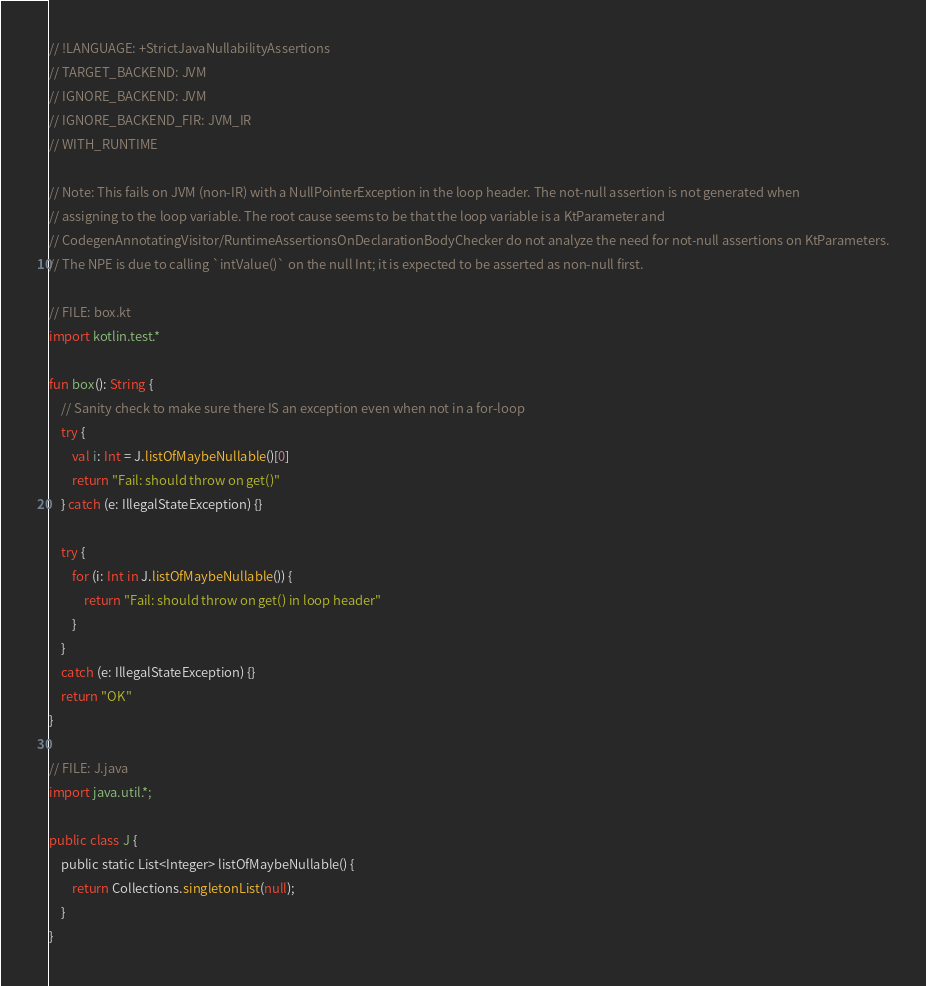Convert code to text. <code><loc_0><loc_0><loc_500><loc_500><_Kotlin_>// !LANGUAGE: +StrictJavaNullabilityAssertions
// TARGET_BACKEND: JVM
// IGNORE_BACKEND: JVM
// IGNORE_BACKEND_FIR: JVM_IR
// WITH_RUNTIME

// Note: This fails on JVM (non-IR) with a NullPointerException in the loop header. The not-null assertion is not generated when
// assigning to the loop variable. The root cause seems to be that the loop variable is a KtParameter and
// CodegenAnnotatingVisitor/RuntimeAssertionsOnDeclarationBodyChecker do not analyze the need for not-null assertions on KtParameters.
// The NPE is due to calling `intValue()` on the null Int; it is expected to be asserted as non-null first.

// FILE: box.kt
import kotlin.test.*

fun box(): String {
    // Sanity check to make sure there IS an exception even when not in a for-loop
    try {
        val i: Int = J.listOfMaybeNullable()[0]
        return "Fail: should throw on get()"
    } catch (e: IllegalStateException) {}

    try {
        for (i: Int in J.listOfMaybeNullable()) {
            return "Fail: should throw on get() in loop header"
        }
    }
    catch (e: IllegalStateException) {}
    return "OK"
}

// FILE: J.java
import java.util.*;

public class J {
    public static List<Integer> listOfMaybeNullable() {
        return Collections.singletonList(null);
    }
}
</code> 